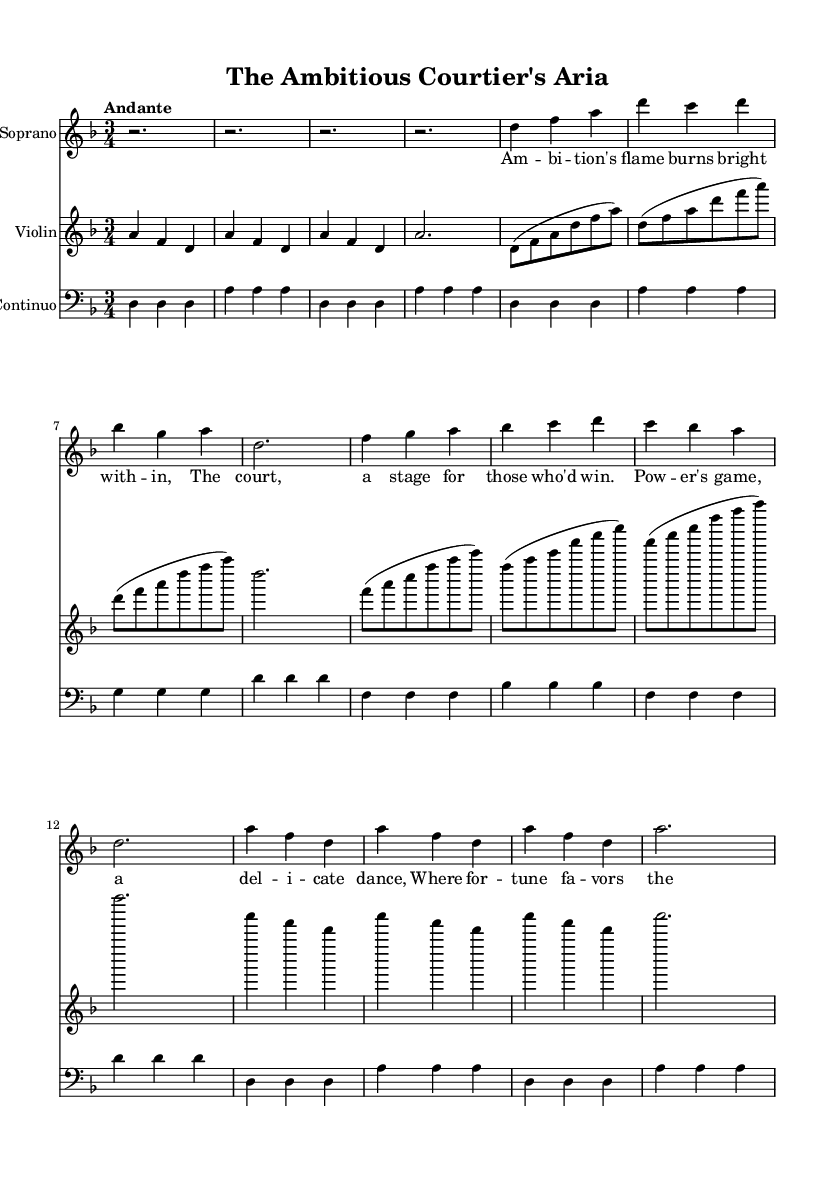What is the key signature of this music? The key signature shows one flat, indicating it is in D minor.
Answer: D minor What is the time signature? The time signature is indicated as 3/4, meaning there are three beats per measure and the quarter note gets one beat.
Answer: 3/4 What is the tempo marking? The tempo marking at the beginning of the score indicates a pace of "Andante," which typically means a moderately slow tempo.
Answer: Andante How many measures are in the introduction section? The introduction consists of four measures, as indicated by the rests and notes present in that section.
Answer: 4 What instrument plays the principal melody in the score? The soprano instrument carries the principal melody and lyrics throughout the composition, made evident by its prominent role and placement.
Answer: Soprano In which section do we notice a ritornello? The ritornello section is noted after the verse, as it specifically marks a return to a previously established musical theme or phrase, indicated by the notes listed under such a label.
Answer: Ritornello What lyrical theme does the aria represent? The lyrics depict ambition and political intrigue, which mirrors the context of courtiers striving for power in a royal setting, as expressed in the text of the aria.
Answer: Ambition 